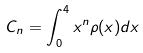Convert formula to latex. <formula><loc_0><loc_0><loc_500><loc_500>C _ { n } = \int _ { 0 } ^ { 4 } x ^ { n } \rho ( x ) d x</formula> 